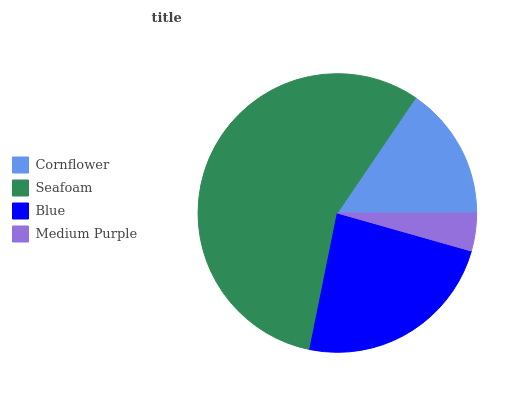Is Medium Purple the minimum?
Answer yes or no. Yes. Is Seafoam the maximum?
Answer yes or no. Yes. Is Blue the minimum?
Answer yes or no. No. Is Blue the maximum?
Answer yes or no. No. Is Seafoam greater than Blue?
Answer yes or no. Yes. Is Blue less than Seafoam?
Answer yes or no. Yes. Is Blue greater than Seafoam?
Answer yes or no. No. Is Seafoam less than Blue?
Answer yes or no. No. Is Blue the high median?
Answer yes or no. Yes. Is Cornflower the low median?
Answer yes or no. Yes. Is Seafoam the high median?
Answer yes or no. No. Is Blue the low median?
Answer yes or no. No. 